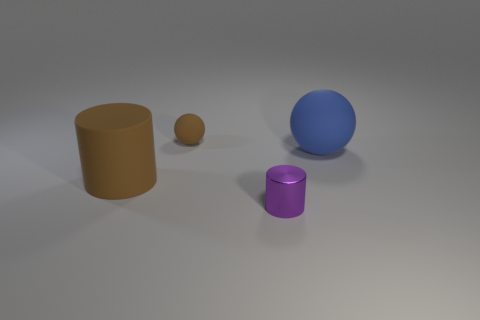What color is the cylinder that is made of the same material as the tiny brown ball?
Your response must be concise. Brown. Are there more purple objects than blocks?
Offer a terse response. Yes. How many objects are either matte things that are to the left of the tiny brown ball or small red rubber cylinders?
Offer a terse response. 1. Is there a green object of the same size as the purple object?
Provide a succinct answer. No. Are there fewer large purple metal blocks than matte cylinders?
Make the answer very short. Yes. What number of cubes are large brown things or tiny rubber objects?
Ensure brevity in your answer.  0. How many tiny rubber spheres have the same color as the large rubber cylinder?
Keep it short and to the point. 1. How big is the thing that is both to the left of the purple shiny cylinder and in front of the big blue matte sphere?
Your answer should be very brief. Large. Are there fewer blue rubber things right of the big cylinder than matte cylinders?
Ensure brevity in your answer.  No. Do the large brown thing and the brown sphere have the same material?
Make the answer very short. Yes. 